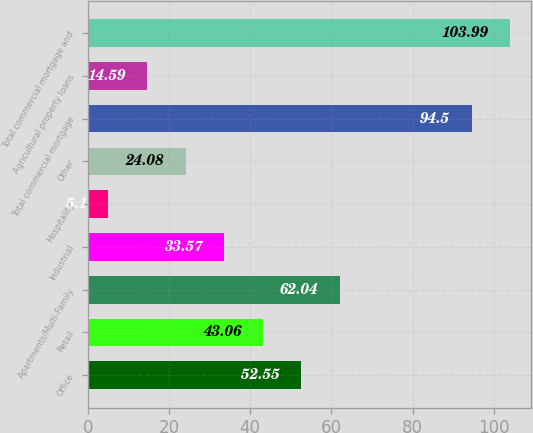<chart> <loc_0><loc_0><loc_500><loc_500><bar_chart><fcel>Office<fcel>Retail<fcel>Apartments/Multi-Family<fcel>Industrial<fcel>Hospitality<fcel>Other<fcel>Total commercial mortgage<fcel>Agricultural property loans<fcel>Total commercial mortgage and<nl><fcel>52.55<fcel>43.06<fcel>62.04<fcel>33.57<fcel>5.1<fcel>24.08<fcel>94.5<fcel>14.59<fcel>103.99<nl></chart> 